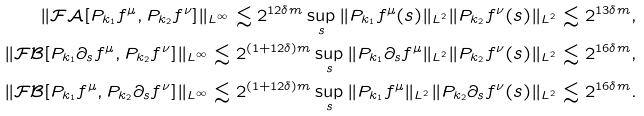Convert formula to latex. <formula><loc_0><loc_0><loc_500><loc_500>\| \mathcal { F } \mathcal { A } [ P _ { k _ { 1 } } f ^ { \mu } , P _ { k _ { 2 } } f ^ { \nu } ] \| _ { L ^ { \infty } } \lesssim 2 ^ { 1 2 \delta m } \sup _ { s } \| P _ { k _ { 1 } } f ^ { \mu } ( s ) \| _ { L ^ { 2 } } \| P _ { k _ { 2 } } f ^ { \nu } ( s ) \| _ { L ^ { 2 } } \lesssim 2 ^ { 1 3 \delta m } , \\ \| \mathcal { F } \mathcal { B } [ P _ { k _ { 1 } } \partial _ { s } f ^ { \mu } , P _ { k _ { 2 } } f ^ { \nu } ] \| _ { L ^ { \infty } } \lesssim 2 ^ { ( 1 + 1 2 \delta ) m } \sup _ { s } \| P _ { k _ { 1 } } \partial _ { s } f ^ { \mu } \| _ { L ^ { 2 } } \| P _ { k _ { 2 } } f ^ { \nu } ( s ) \| _ { L ^ { 2 } } \lesssim 2 ^ { 1 6 \delta m } , \\ \| \mathcal { F } \mathcal { B } [ P _ { k _ { 1 } } f ^ { \mu } , P _ { k _ { 2 } } \partial _ { s } f ^ { \nu } ] \| _ { L ^ { \infty } } \lesssim 2 ^ { ( 1 + 1 2 \delta ) m } \sup _ { s } \| P _ { k _ { 1 } } f ^ { \mu } \| _ { L ^ { 2 } } \| P _ { k _ { 2 } } \partial _ { s } f ^ { \nu } ( s ) \| _ { L ^ { 2 } } \lesssim 2 ^ { 1 6 \delta m } .</formula> 